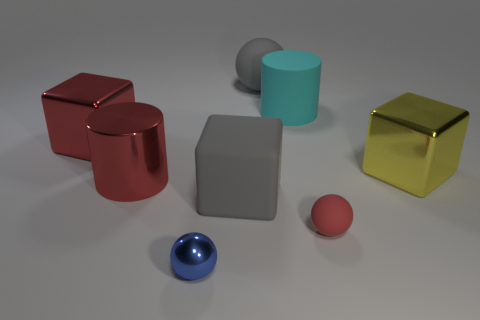Can you tell me about the different textures or materials visible in the image? Certainly! In the image, we observe a variety of textures: the red and gold cubes exhibit a shiny, metallic finish, reflecting light vigorously. The large gray cube has a matte surface, absorbing more light than it reflects, which suggests a non-metallic material. The cylindrical objects, one cyan and one red, both show a smoother, metallic sheen. The small red sphere appears to have a rubber-like finish, with a less reflective surface, meanwhile the blue sphere displays glossy characteristics like those of polished metal or glass. 